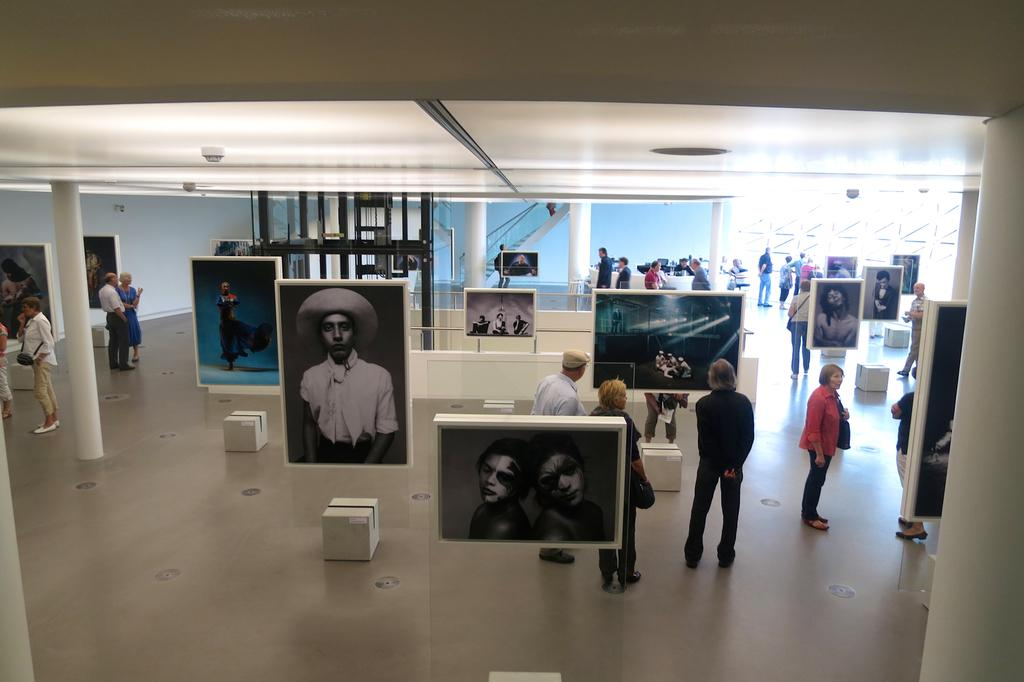What type of establishment is depicted in the image? There is a photo gallery in the image. How many people are present in the photo gallery? Many people are standing in the photo gallery. What are the people doing in the photo gallery? The people are looking at photographs. What is the color of the roof and pillars in the photo gallery? The roof and pillars of the photo gallery are white. What is the color of the floor in the photo gallery? The floor of the photo gallery is light brown. What type of summer activity is taking place in the photo gallery? There is no mention of summer or any specific activity in the image; it simply shows people looking at photographs in a photo gallery. 